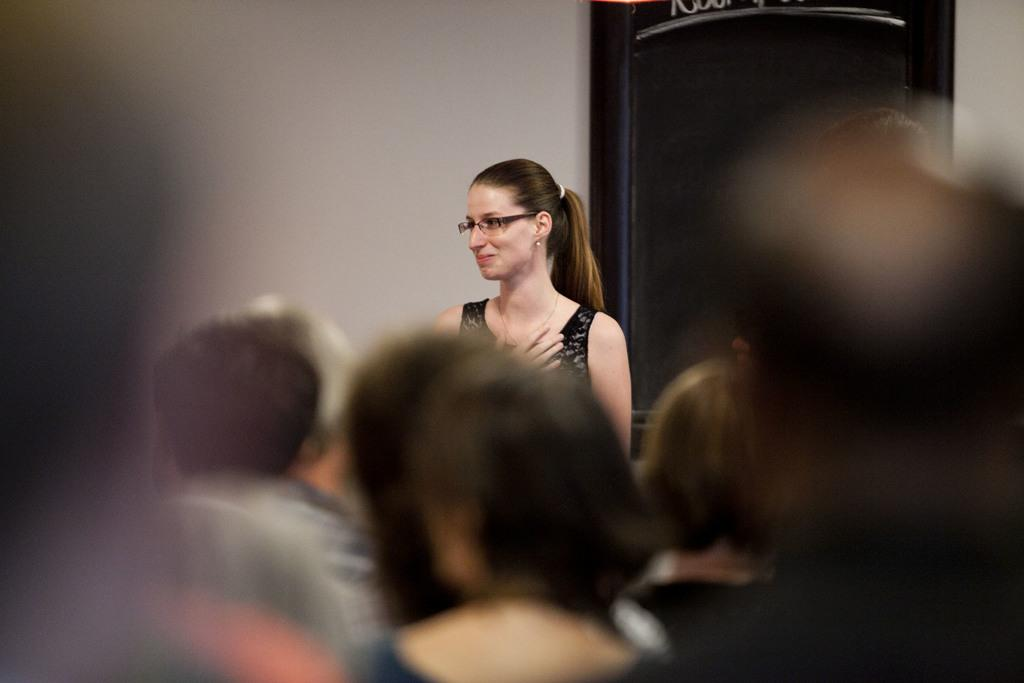What is the main subject of the image? There is a woman standing in the image. Can you describe the positioning of the people in the image? There are people in front of the woman in the image. What type of bun is the woman holding in the image? There is no bun present in the image. How does the woman's breath affect the people in front of her in the image? There is no indication of the woman's breath affecting the people in front of her in the image. 